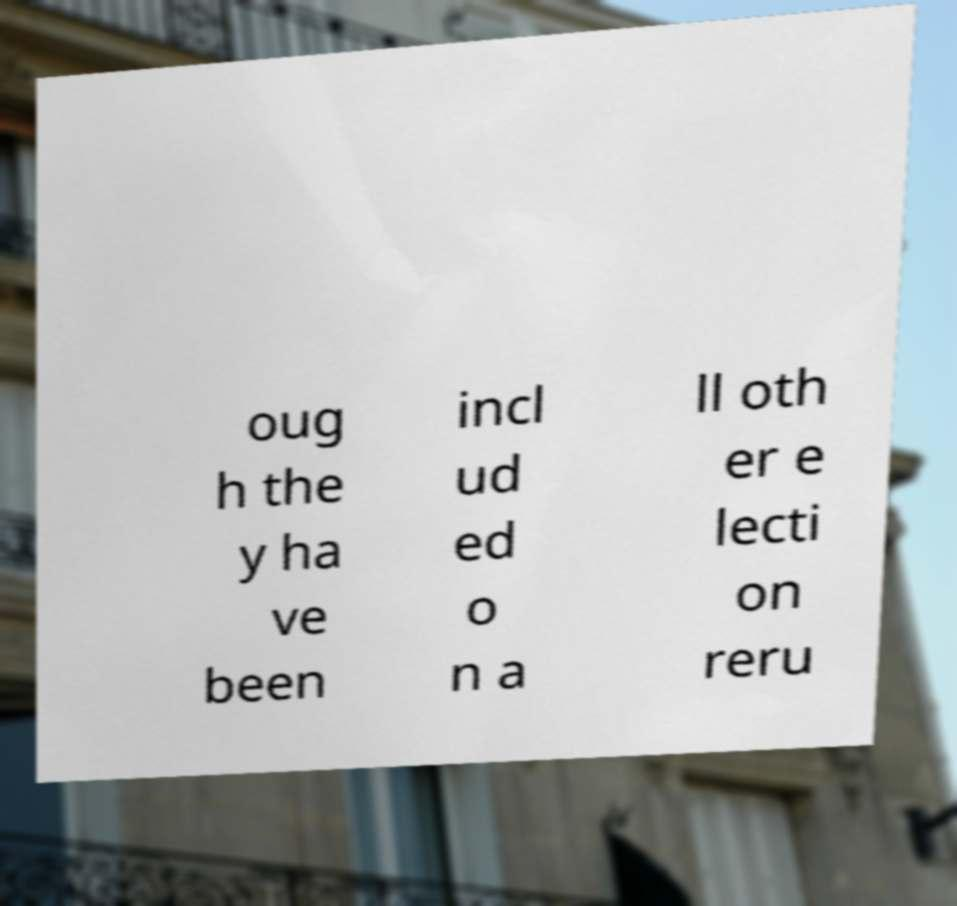For documentation purposes, I need the text within this image transcribed. Could you provide that? oug h the y ha ve been incl ud ed o n a ll oth er e lecti on reru 